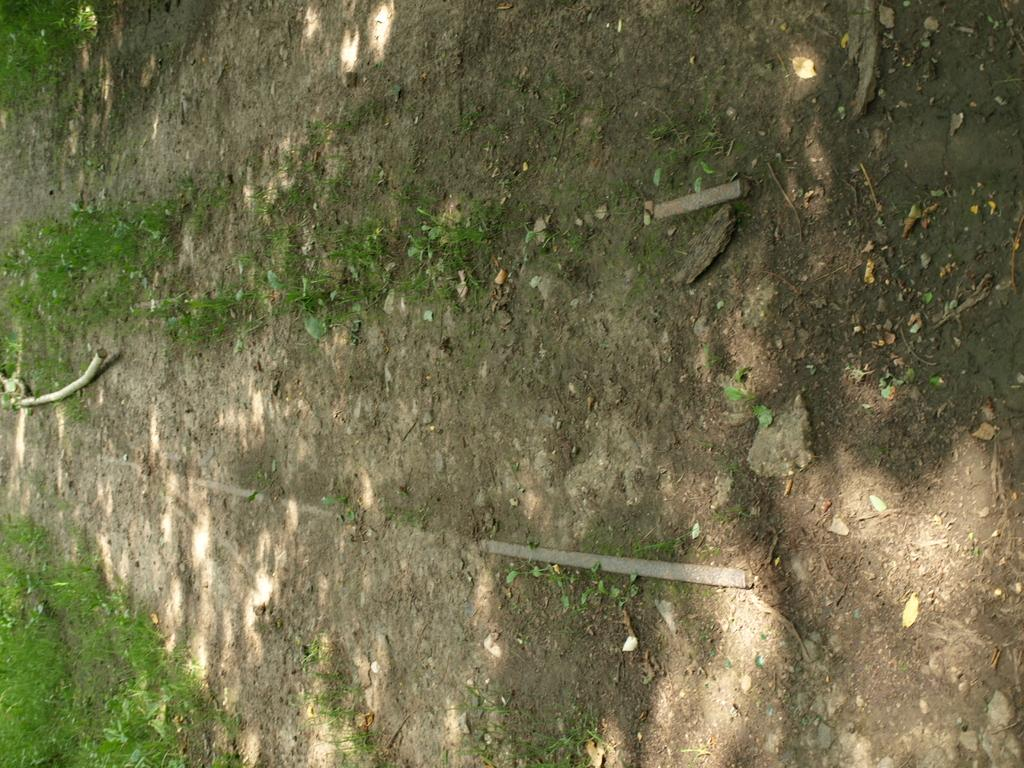What type of ground is visible in the image? The ground in the image is dirt. What object can be seen on the left side of the image? There is a stick on the left side of the image. What type of vegetation is present on the left side of the image? There is grass on the left side of the image. How many glasses of wine can be seen in the image? There are no glasses of wine present in the image. What type of fish is swimming in the grass on the left side of the image? There are no fish present in the image, and the grass is not a body of water where fish would swim. 